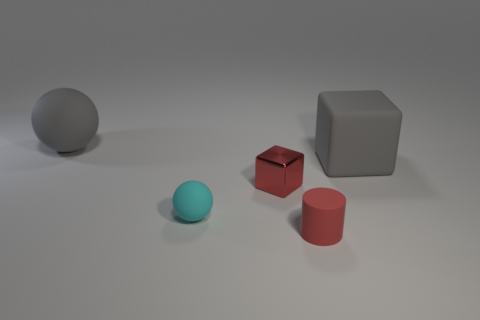Add 3 cyan matte objects. How many objects exist? 8 Subtract all blocks. How many objects are left? 3 Subtract 2 blocks. How many blocks are left? 0 Subtract all blue spheres. Subtract all red cylinders. How many spheres are left? 2 Subtract all tiny red rubber cylinders. Subtract all tiny cylinders. How many objects are left? 3 Add 1 red rubber cylinders. How many red rubber cylinders are left? 2 Add 1 large spheres. How many large spheres exist? 2 Subtract all red blocks. How many blocks are left? 1 Subtract 1 red cylinders. How many objects are left? 4 